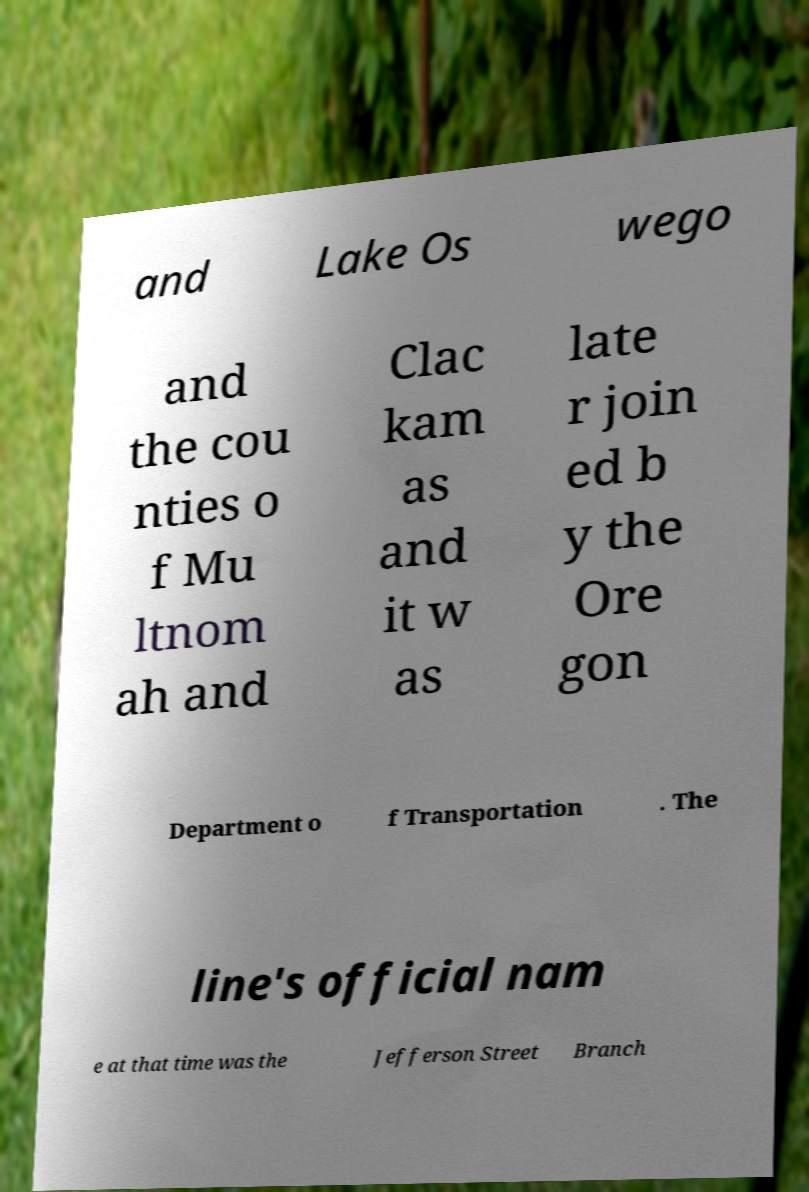There's text embedded in this image that I need extracted. Can you transcribe it verbatim? and Lake Os wego and the cou nties o f Mu ltnom ah and Clac kam as and it w as late r join ed b y the Ore gon Department o f Transportation . The line's official nam e at that time was the Jefferson Street Branch 